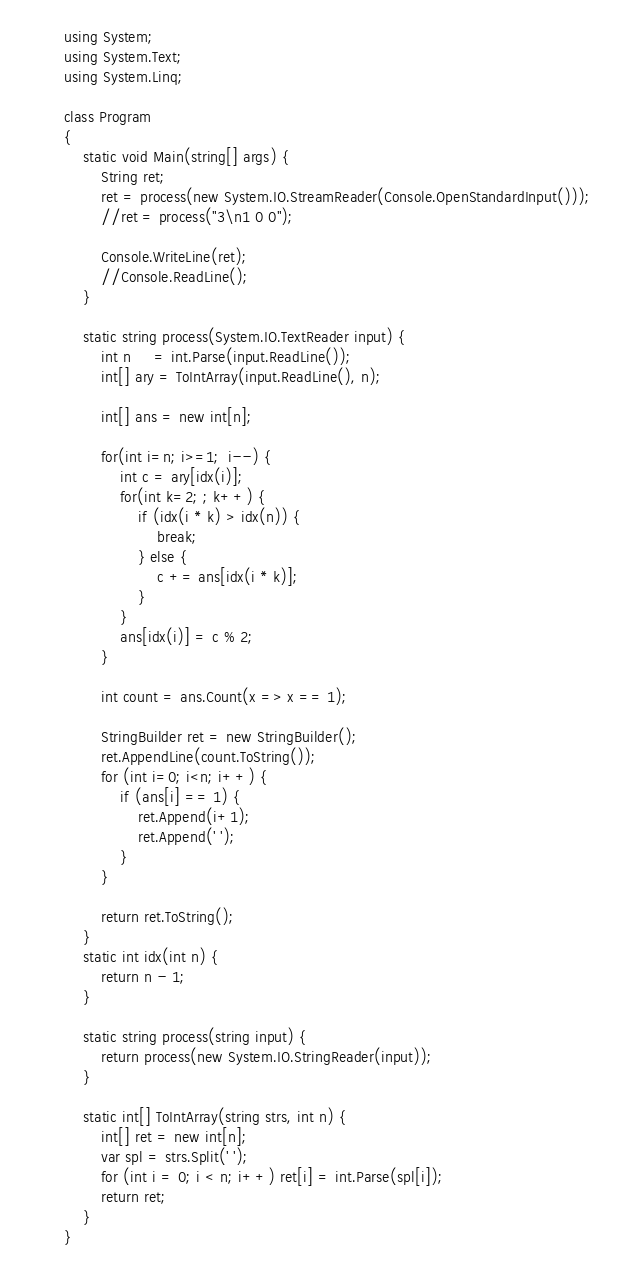<code> <loc_0><loc_0><loc_500><loc_500><_C#_>using System;
using System.Text;
using System.Linq;

class Program
{
    static void Main(string[] args) {
        String ret;
        ret = process(new System.IO.StreamReader(Console.OpenStandardInput()));
        //ret = process("3\n1 0 0");

        Console.WriteLine(ret);
        //Console.ReadLine();
    }

    static string process(System.IO.TextReader input) {
        int n     = int.Parse(input.ReadLine());
        int[] ary = ToIntArray(input.ReadLine(), n);

        int[] ans = new int[n];

        for(int i=n; i>=1;  i--) {
            int c = ary[idx(i)];
            for(int k=2; ; k++) {
                if (idx(i * k) > idx(n)) {
                    break;
                } else {
                    c += ans[idx(i * k)];
                }
            }
            ans[idx(i)] = c % 2;
        }

        int count = ans.Count(x => x == 1);
        
        StringBuilder ret = new StringBuilder();
        ret.AppendLine(count.ToString());
        for (int i=0; i<n; i++) {
            if (ans[i] == 1) {
                ret.Append(i+1);
                ret.Append(' ');
            }
        }

        return ret.ToString();
    }
    static int idx(int n) {
        return n - 1;
    }

    static string process(string input) {
        return process(new System.IO.StringReader(input));
    }

    static int[] ToIntArray(string strs, int n) {
        int[] ret = new int[n];
        var spl = strs.Split(' ');
        for (int i = 0; i < n; i++) ret[i] = int.Parse(spl[i]);
        return ret;
    }
}</code> 